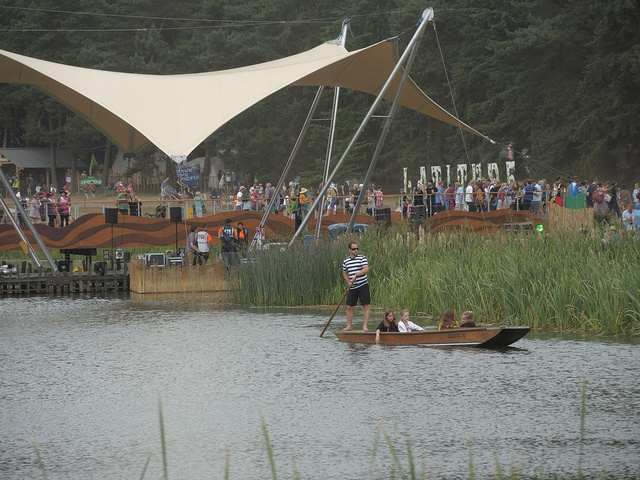Describe the objects in this image and their specific colors. I can see people in black and gray tones, boat in black, brown, and gray tones, people in black, gray, and darkgray tones, people in black, darkgray, gray, and maroon tones, and people in black, gray, and maroon tones in this image. 